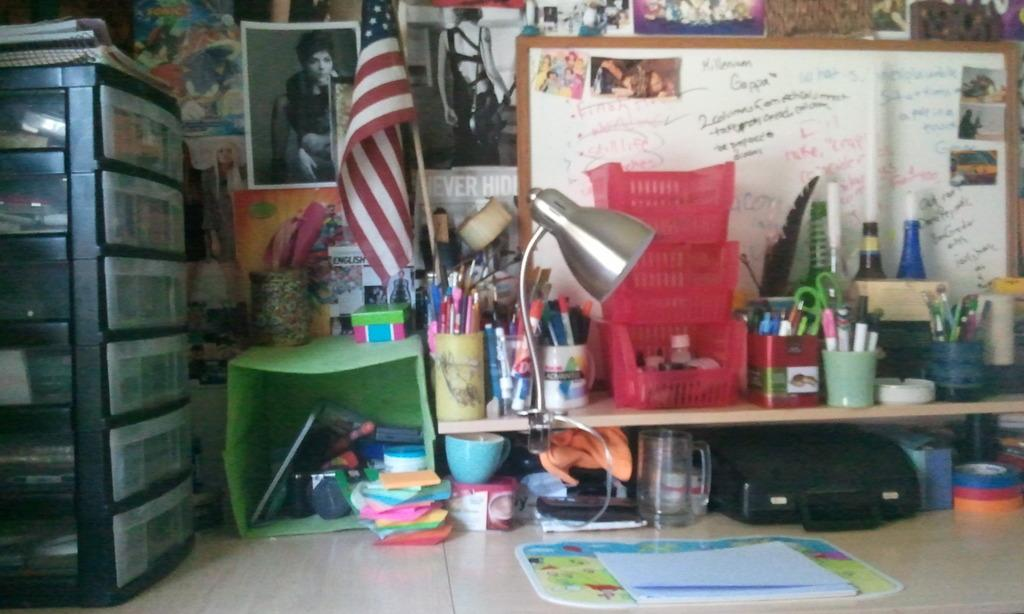<image>
Give a short and clear explanation of the subsequent image. a desk with a white board with words and numbers like 2 on it 